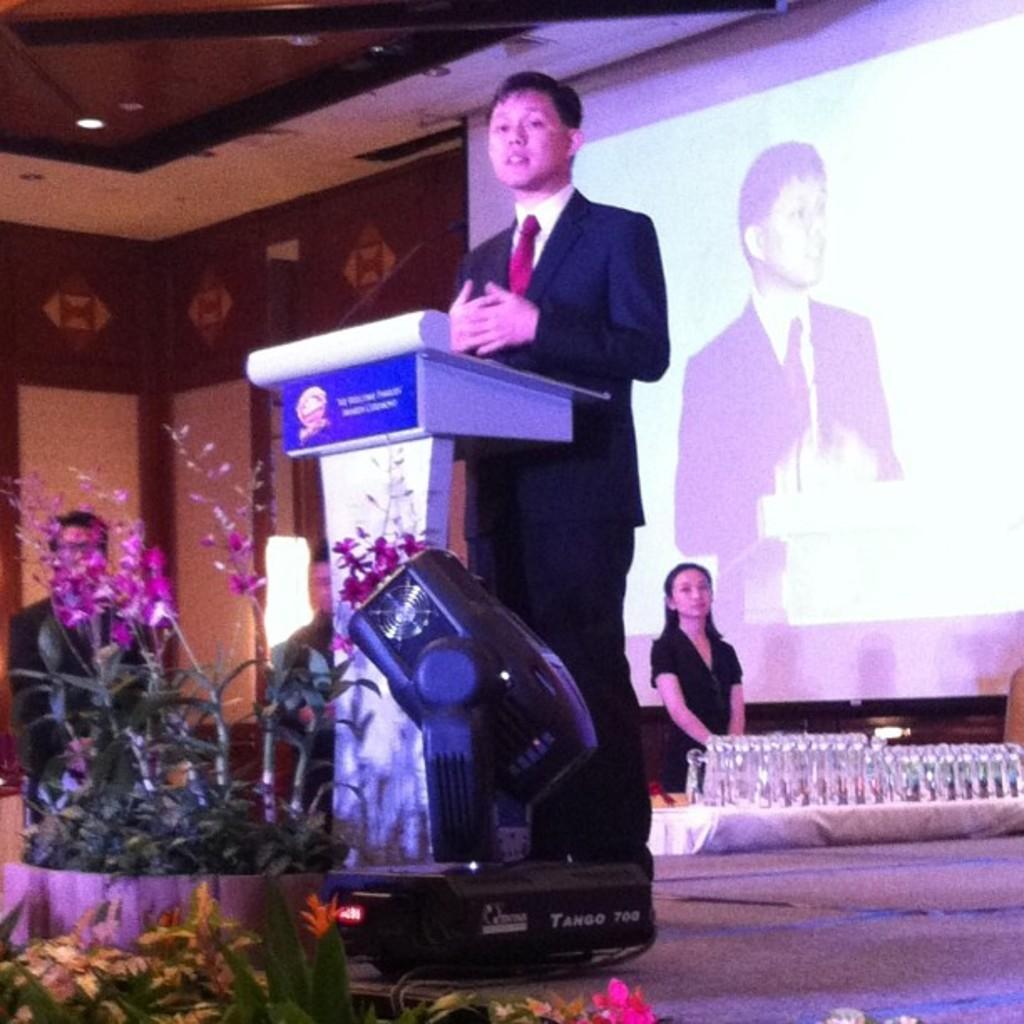In one or two sentences, can you explain what this image depicts? This picture seems to be clicked inside the hall. In the foreground we can see the green leaves, flowers and a focusing light and we can see a person wearing suit and standing behind the podium. In the background we can see the group of persons seems to be sitting and we can see a person wearing black color dress and standing and we can see some glass objects. At the top there is a roof and the ceiling lights. In the background we can see the wall and a projector screen on which we can see the picture of a person and a picture of a podium and we can see some other objects and a light. 